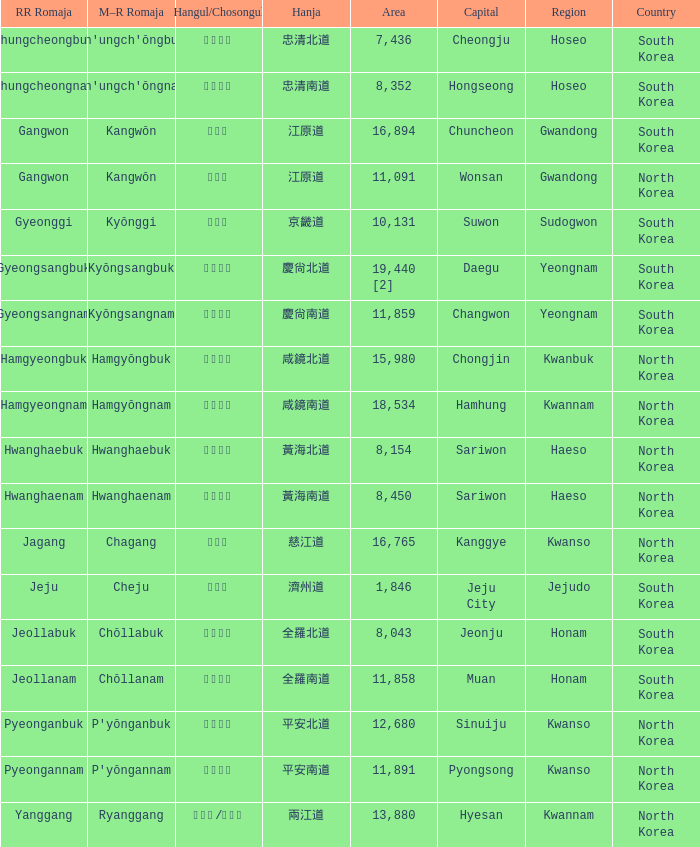How large is the province that has the hangul designation 경기도? 10131.0. 